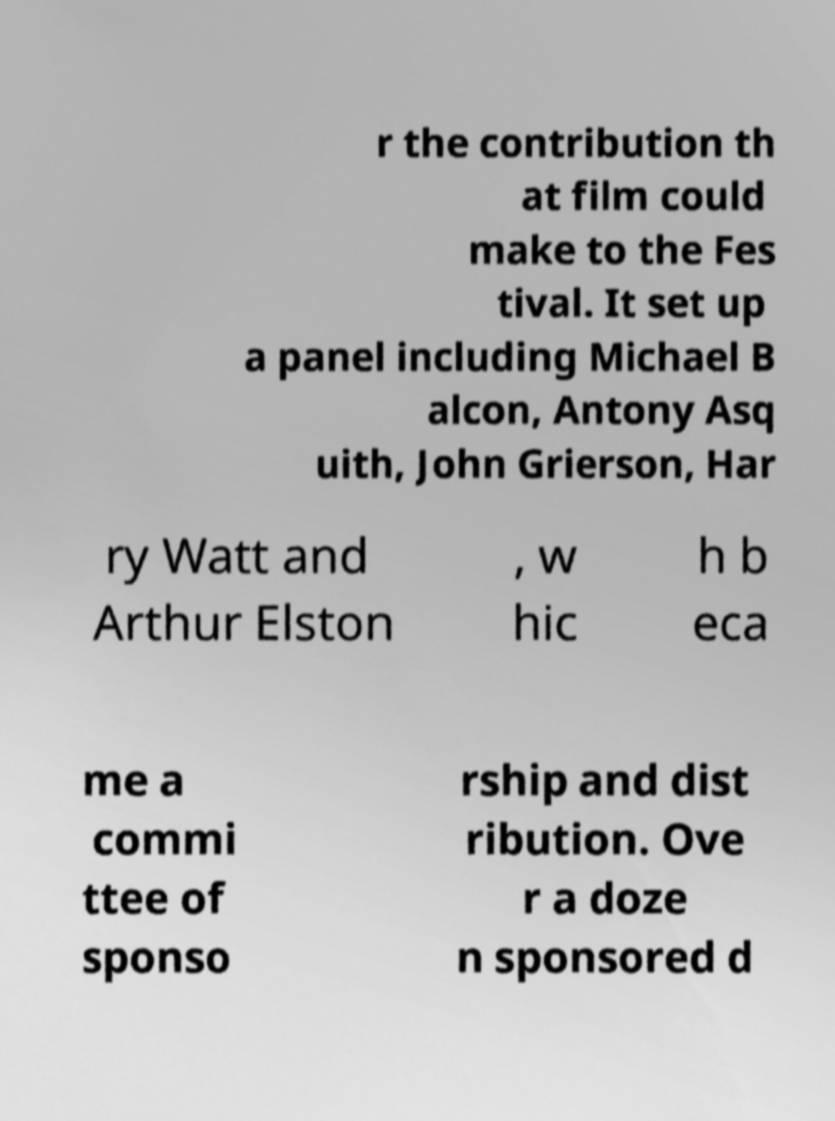Could you assist in decoding the text presented in this image and type it out clearly? r the contribution th at film could make to the Fes tival. It set up a panel including Michael B alcon, Antony Asq uith, John Grierson, Har ry Watt and Arthur Elston , w hic h b eca me a commi ttee of sponso rship and dist ribution. Ove r a doze n sponsored d 